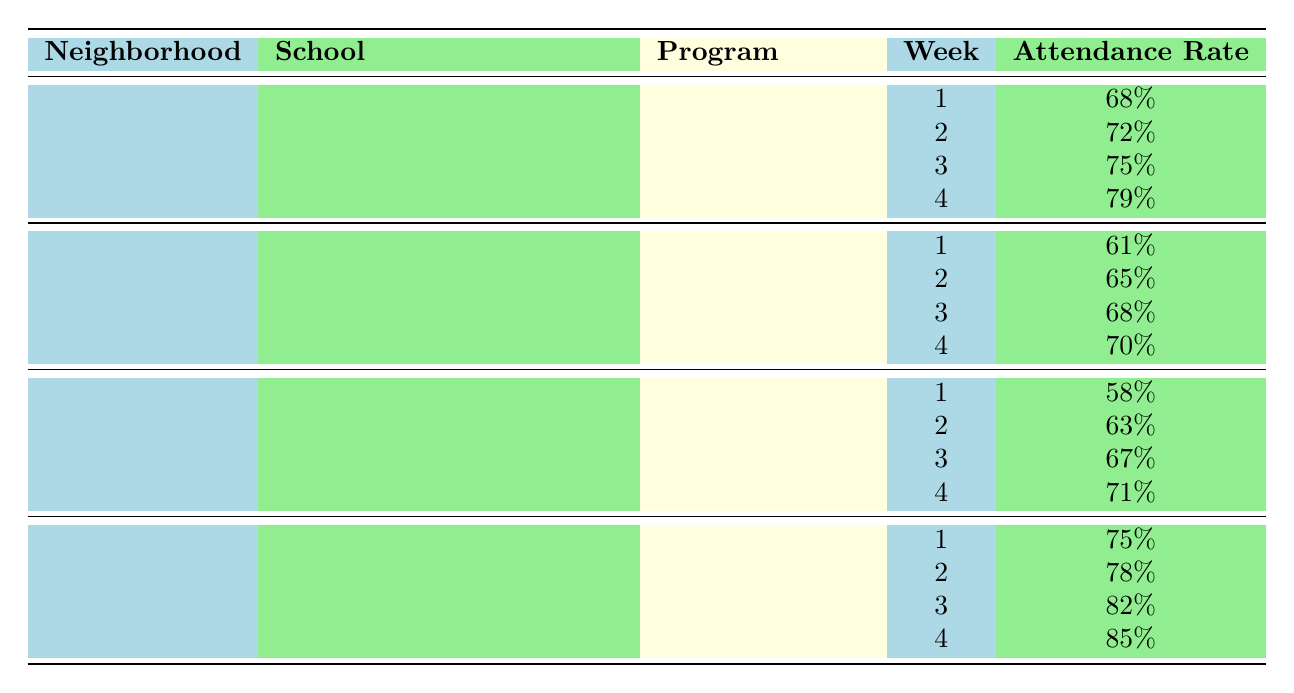What is the attendance rate for the "Math Boost" program in week 3? According to the table, the attendance rate for the "Math Boost" program in Brownsville, PS 156 Waverly for week 3 is 75%.
Answer: 75% Which program had the highest attendance rate in week 4? The table shows that in week 4, the "College Prep" program from Harlem had the highest attendance rate of 85%.
Answer: 85% What is the average attendance rate for the "Science Explorers" program? The attendance rates for "Science Explorers" are 58%, 63%, 67%, and 71%. To find the average, sum these values: 58 + 63 + 67 + 71 = 259. Then divide by 4: 259 / 4 = 64.75%.
Answer: 64.75% Is the attendance rate for "Reading Warriors" in week 2 higher than the attendance rate for "Math Boost" in week 1? The attendance rate for "Reading Warriors" in week 2 is 65%, while the rate for "Math Boost" in week 1 is 68%. Since 65% is less than 68%, the answer is no.
Answer: No What is the difference in attendance rates between the "College Prep" program in week 1 and the "Science Explorers" program in week 4? The attendance rate for "College Prep" in week 1 is 75%, and for "Science Explorers" in week 4 is 71%. The difference is 75% - 71% = 4%.
Answer: 4% Which program has the lowest attendance rate and what is that rate? In the table, the "Science Explorers" program in week 1 has the lowest attendance rate of 58%.
Answer: 58% How does the attendance rate for "Math Boost" in week 4 compare to the average attendance rate of all programs in week 4? The attendance rate for "Math Boost" in week 4 is 79%. For all programs in week 4, the rates are 79% (Math Boost), 70% (Reading Warriors), 71% (Science Explorers), and 85% (College Prep). The average is (79 + 70 + 71 + 85) / 4 = 76.25%. Since 79% is higher than 76.25%, it can be said that "Math Boost" in week 4 is higher than the average.
Answer: Higher In how many weeks did "College Prep" have an attendance rate above 80%? The attendance rates for "College Prep" are 75%, 78%, 82%, and 85% over four weeks. The rates above 80% are in week 3 (82%) and week 4 (85%). Thus, it is 2 weeks.
Answer: 2 What is the total attendance rate for "Reading Warriors" over all four weeks? The attendance rates for "Reading Warriors" are 61%, 65%, 68%, and 70%. Summing these gives: 61 + 65 + 68 + 70 = 264%.
Answer: 264% 